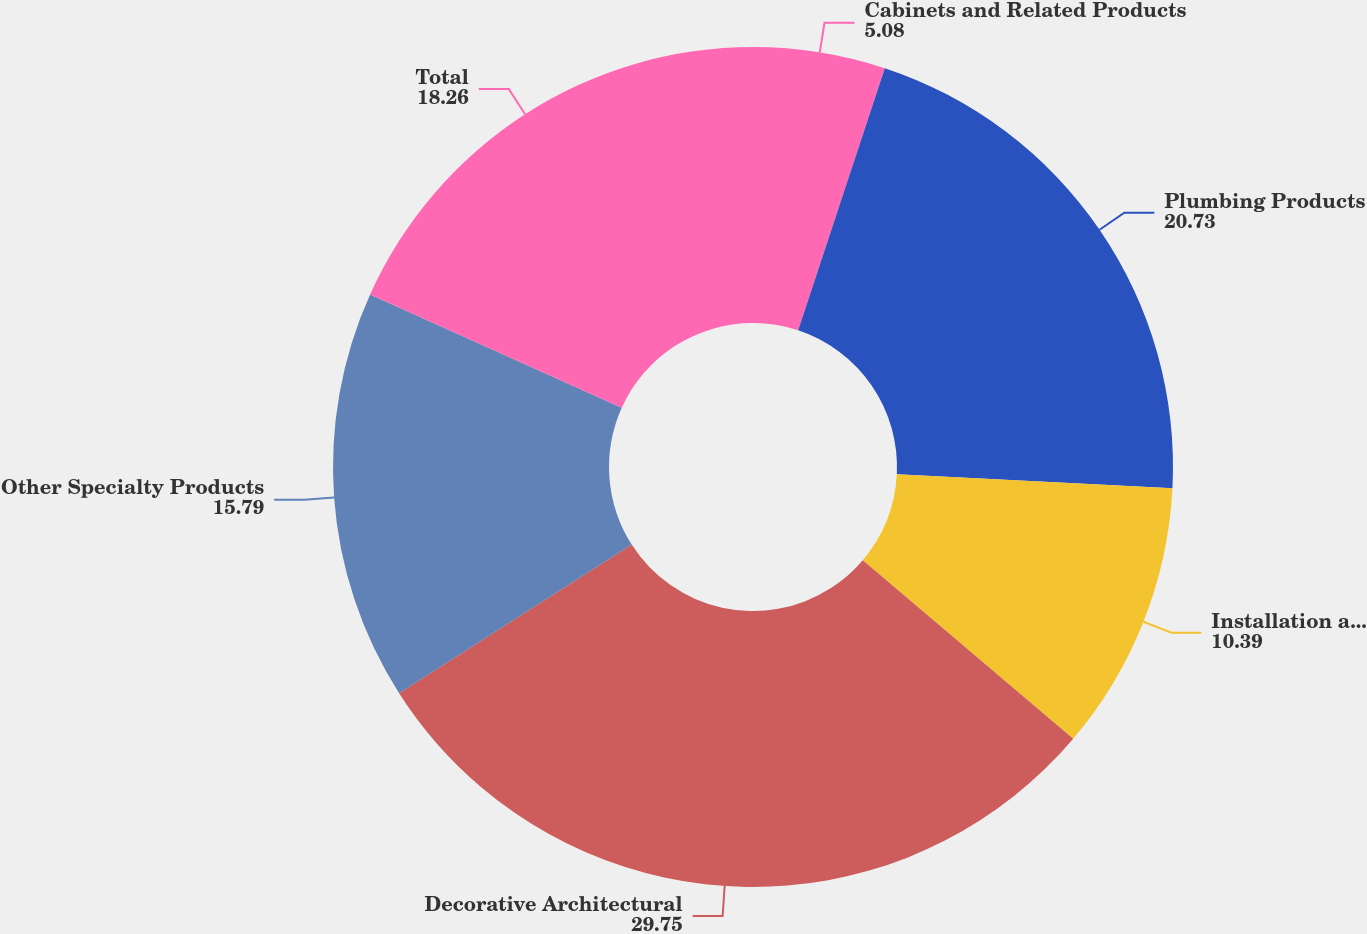Convert chart. <chart><loc_0><loc_0><loc_500><loc_500><pie_chart><fcel>Cabinets and Related Products<fcel>Plumbing Products<fcel>Installation and Other<fcel>Decorative Architectural<fcel>Other Specialty Products<fcel>Total<nl><fcel>5.08%<fcel>20.73%<fcel>10.39%<fcel>29.75%<fcel>15.79%<fcel>18.26%<nl></chart> 